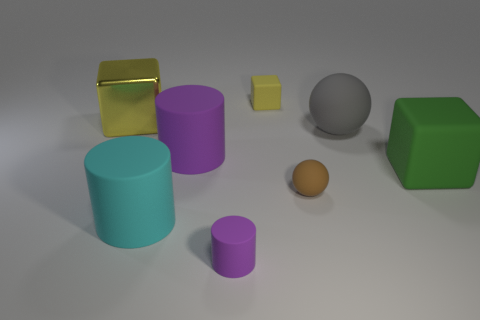Are there any patterns or textures on any of the objects? No, all the objects in the image have solid colors and smooth surfaces without any visible patterns or textures. 